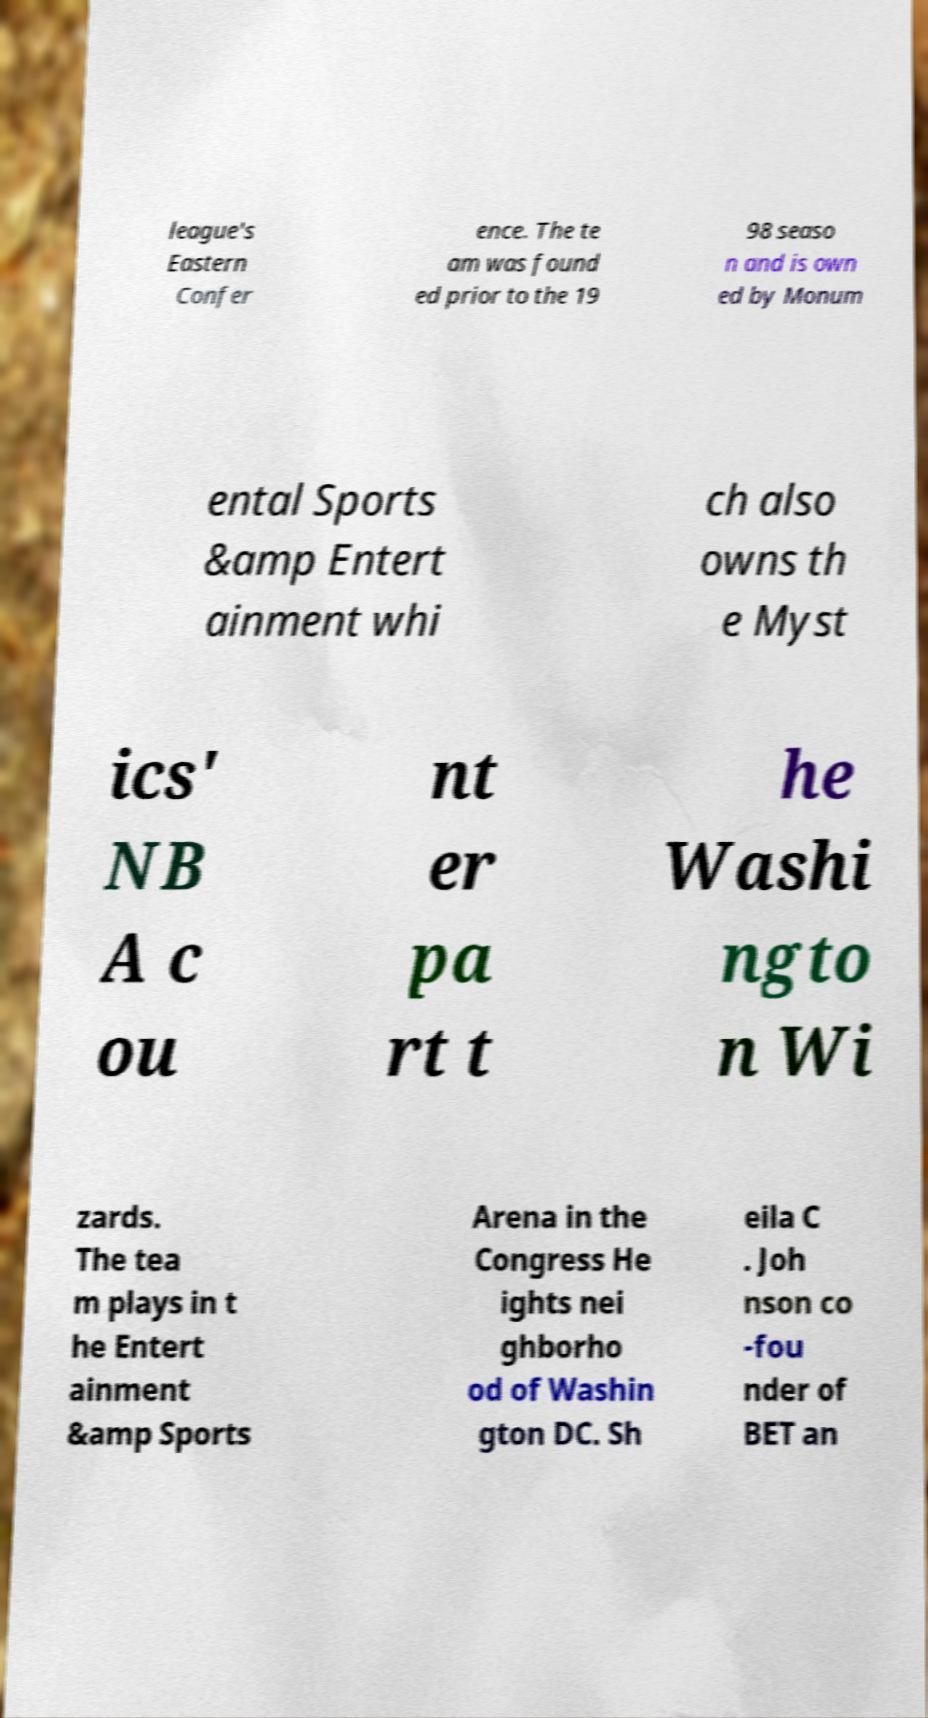Can you accurately transcribe the text from the provided image for me? league's Eastern Confer ence. The te am was found ed prior to the 19 98 seaso n and is own ed by Monum ental Sports &amp Entert ainment whi ch also owns th e Myst ics' NB A c ou nt er pa rt t he Washi ngto n Wi zards. The tea m plays in t he Entert ainment &amp Sports Arena in the Congress He ights nei ghborho od of Washin gton DC. Sh eila C . Joh nson co -fou nder of BET an 